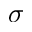<formula> <loc_0><loc_0><loc_500><loc_500>\sigma</formula> 